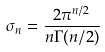<formula> <loc_0><loc_0><loc_500><loc_500>\sigma _ { n } = \frac { 2 \pi ^ { n / 2 } } { n \Gamma ( n / 2 ) }</formula> 